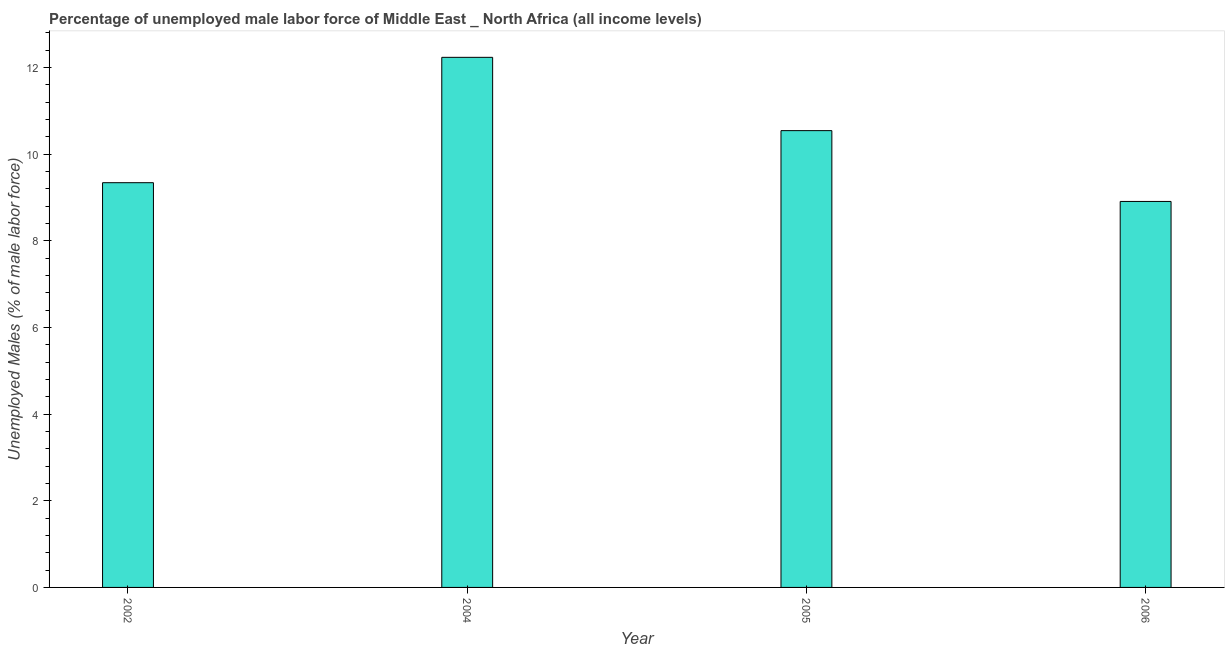What is the title of the graph?
Keep it short and to the point. Percentage of unemployed male labor force of Middle East _ North Africa (all income levels). What is the label or title of the X-axis?
Give a very brief answer. Year. What is the label or title of the Y-axis?
Your answer should be compact. Unemployed Males (% of male labor force). What is the total unemployed male labour force in 2002?
Give a very brief answer. 9.34. Across all years, what is the maximum total unemployed male labour force?
Provide a short and direct response. 12.23. Across all years, what is the minimum total unemployed male labour force?
Keep it short and to the point. 8.91. What is the sum of the total unemployed male labour force?
Keep it short and to the point. 41.02. What is the difference between the total unemployed male labour force in 2005 and 2006?
Give a very brief answer. 1.63. What is the average total unemployed male labour force per year?
Your response must be concise. 10.25. What is the median total unemployed male labour force?
Your response must be concise. 9.94. Do a majority of the years between 2006 and 2004 (inclusive) have total unemployed male labour force greater than 11.6 %?
Provide a succinct answer. Yes. What is the ratio of the total unemployed male labour force in 2002 to that in 2006?
Your response must be concise. 1.05. Is the total unemployed male labour force in 2002 less than that in 2004?
Keep it short and to the point. Yes. What is the difference between the highest and the second highest total unemployed male labour force?
Your answer should be very brief. 1.69. What is the difference between the highest and the lowest total unemployed male labour force?
Give a very brief answer. 3.33. Are all the bars in the graph horizontal?
Keep it short and to the point. No. How many years are there in the graph?
Provide a succinct answer. 4. Are the values on the major ticks of Y-axis written in scientific E-notation?
Your answer should be very brief. No. What is the Unemployed Males (% of male labor force) of 2002?
Your response must be concise. 9.34. What is the Unemployed Males (% of male labor force) of 2004?
Your response must be concise. 12.23. What is the Unemployed Males (% of male labor force) of 2005?
Offer a terse response. 10.54. What is the Unemployed Males (% of male labor force) in 2006?
Make the answer very short. 8.91. What is the difference between the Unemployed Males (% of male labor force) in 2002 and 2004?
Ensure brevity in your answer.  -2.89. What is the difference between the Unemployed Males (% of male labor force) in 2002 and 2005?
Your answer should be very brief. -1.2. What is the difference between the Unemployed Males (% of male labor force) in 2002 and 2006?
Offer a very short reply. 0.43. What is the difference between the Unemployed Males (% of male labor force) in 2004 and 2005?
Keep it short and to the point. 1.69. What is the difference between the Unemployed Males (% of male labor force) in 2004 and 2006?
Ensure brevity in your answer.  3.33. What is the difference between the Unemployed Males (% of male labor force) in 2005 and 2006?
Make the answer very short. 1.63. What is the ratio of the Unemployed Males (% of male labor force) in 2002 to that in 2004?
Provide a succinct answer. 0.76. What is the ratio of the Unemployed Males (% of male labor force) in 2002 to that in 2005?
Ensure brevity in your answer.  0.89. What is the ratio of the Unemployed Males (% of male labor force) in 2002 to that in 2006?
Give a very brief answer. 1.05. What is the ratio of the Unemployed Males (% of male labor force) in 2004 to that in 2005?
Make the answer very short. 1.16. What is the ratio of the Unemployed Males (% of male labor force) in 2004 to that in 2006?
Provide a succinct answer. 1.37. What is the ratio of the Unemployed Males (% of male labor force) in 2005 to that in 2006?
Provide a short and direct response. 1.18. 